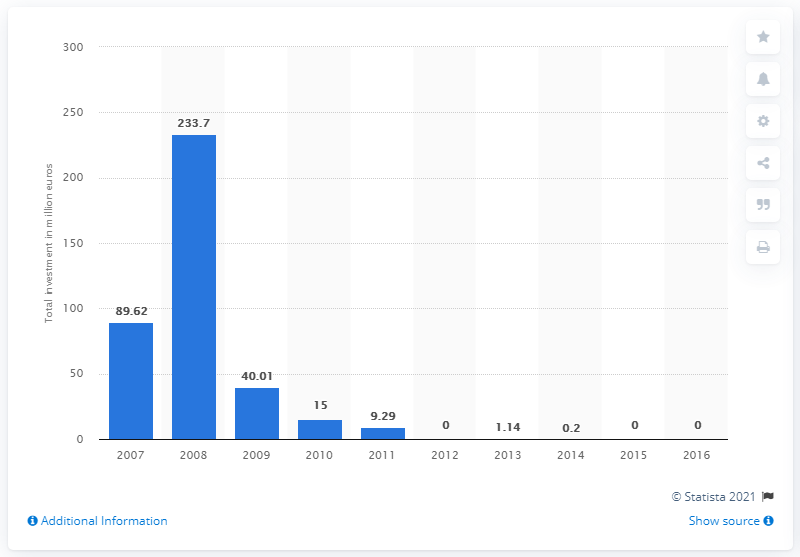Identify some key points in this picture. Private equity investments in Greece in 2014 were valued at approximately 0.2%. The largest total value of private equity investments was found in 2008. 